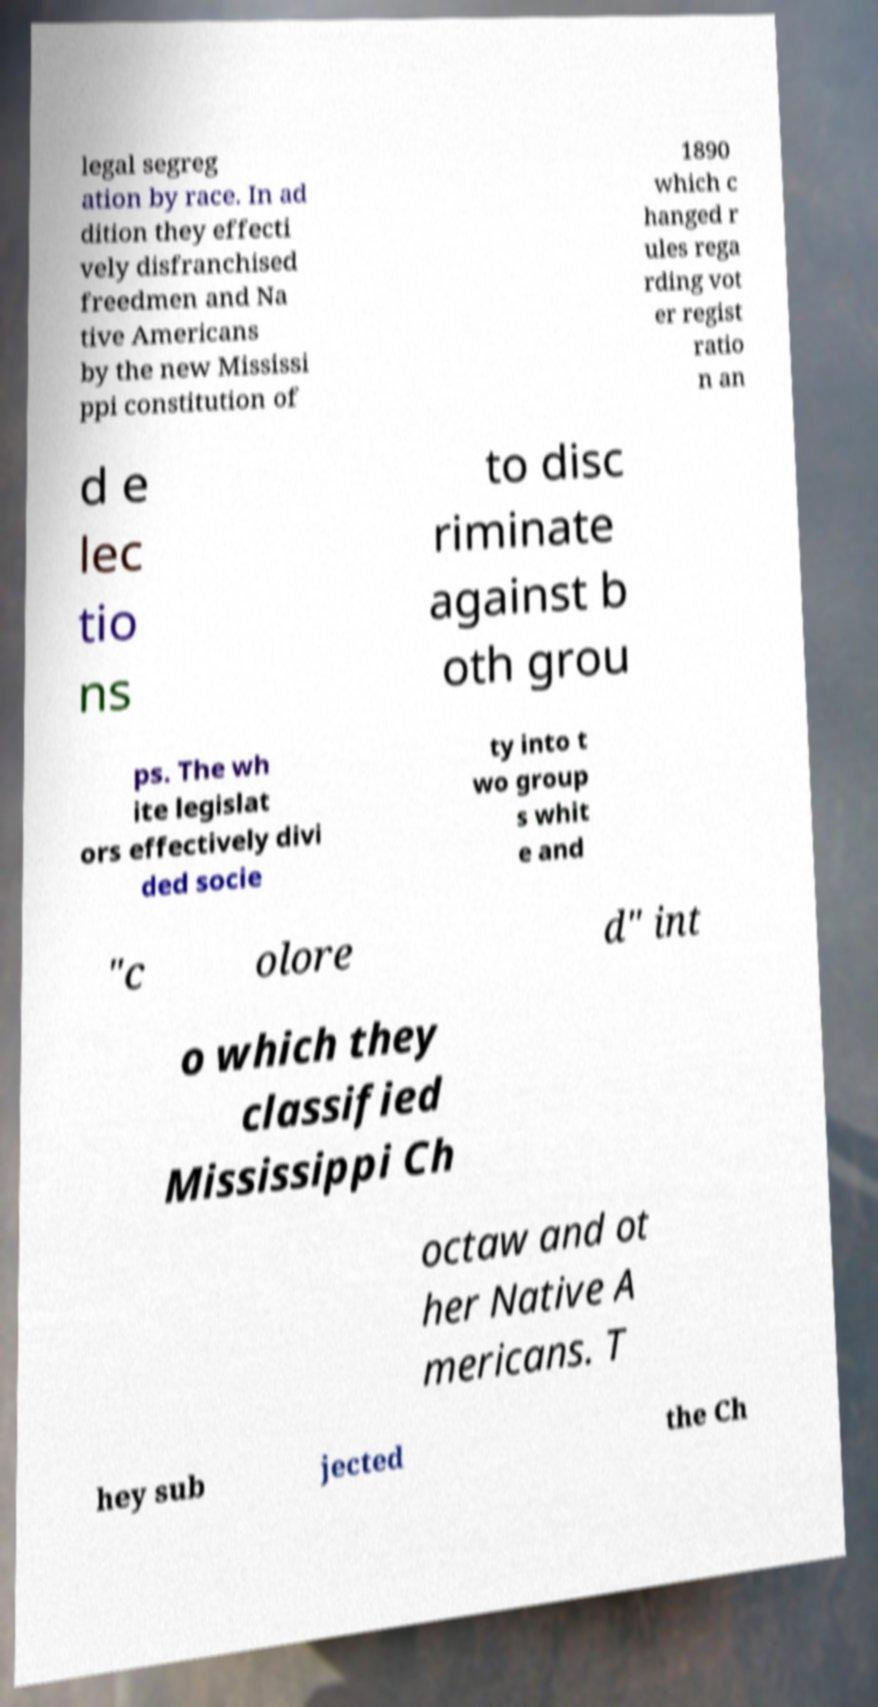What messages or text are displayed in this image? I need them in a readable, typed format. legal segreg ation by race. In ad dition they effecti vely disfranchised freedmen and Na tive Americans by the new Mississi ppi constitution of 1890 which c hanged r ules rega rding vot er regist ratio n an d e lec tio ns to disc riminate against b oth grou ps. The wh ite legislat ors effectively divi ded socie ty into t wo group s whit e and "c olore d" int o which they classified Mississippi Ch octaw and ot her Native A mericans. T hey sub jected the Ch 